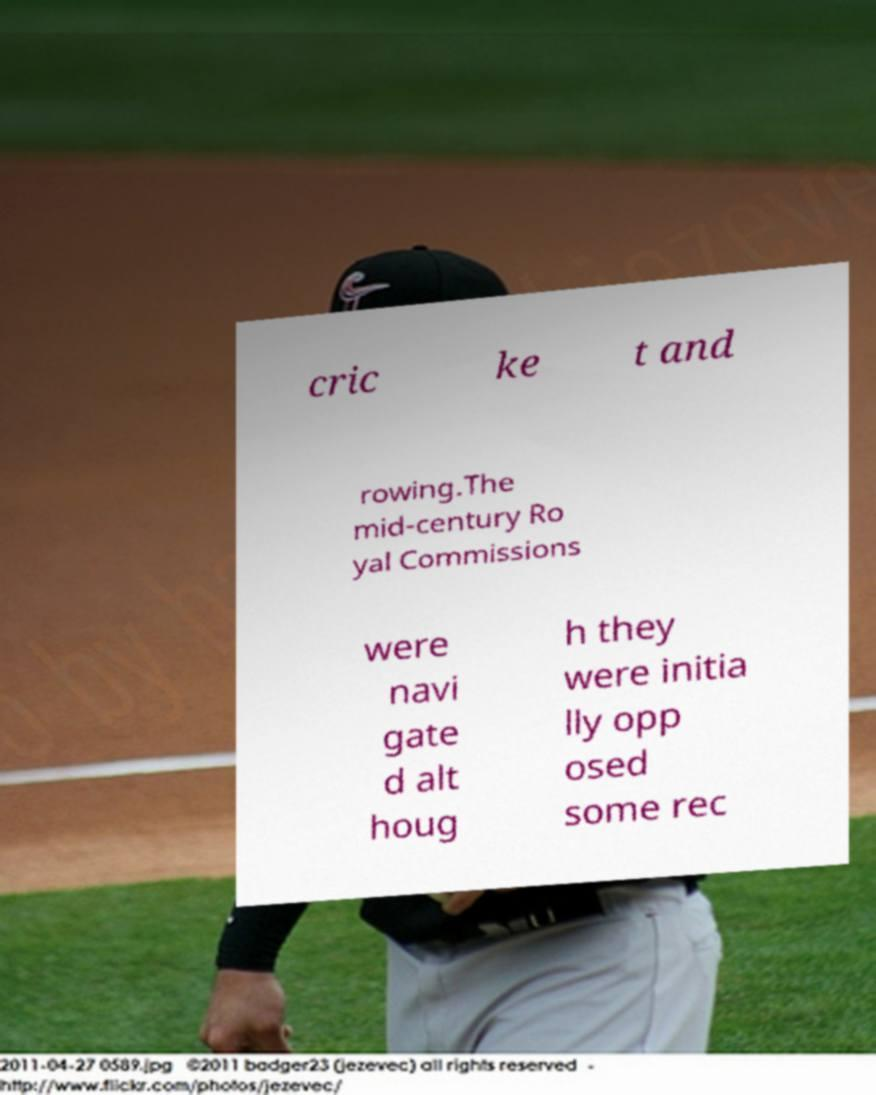Can you read and provide the text displayed in the image?This photo seems to have some interesting text. Can you extract and type it out for me? cric ke t and rowing.The mid-century Ro yal Commissions were navi gate d alt houg h they were initia lly opp osed some rec 